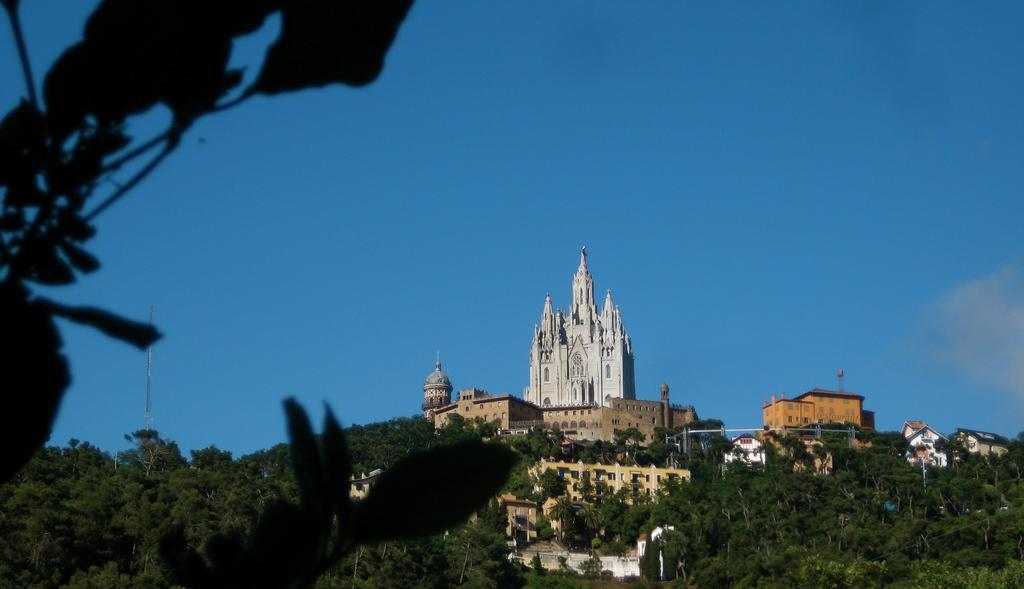What type of vegetation is present in the image? There are trees in the image. What color are the trees? The trees are green. What can be seen in the background of the image? There are buildings in the background of the image. What colors are the buildings? The buildings are white and brown. What color is the sky in the image? The sky is blue. What type of produce is being harvested in the image? There is no produce being harvested in the image; it features trees, buildings, and a blue sky. 